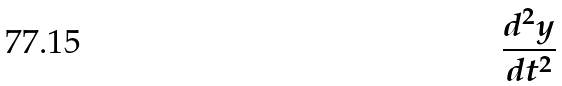Convert formula to latex. <formula><loc_0><loc_0><loc_500><loc_500>\frac { d ^ { 2 } y } { d t ^ { 2 } }</formula> 